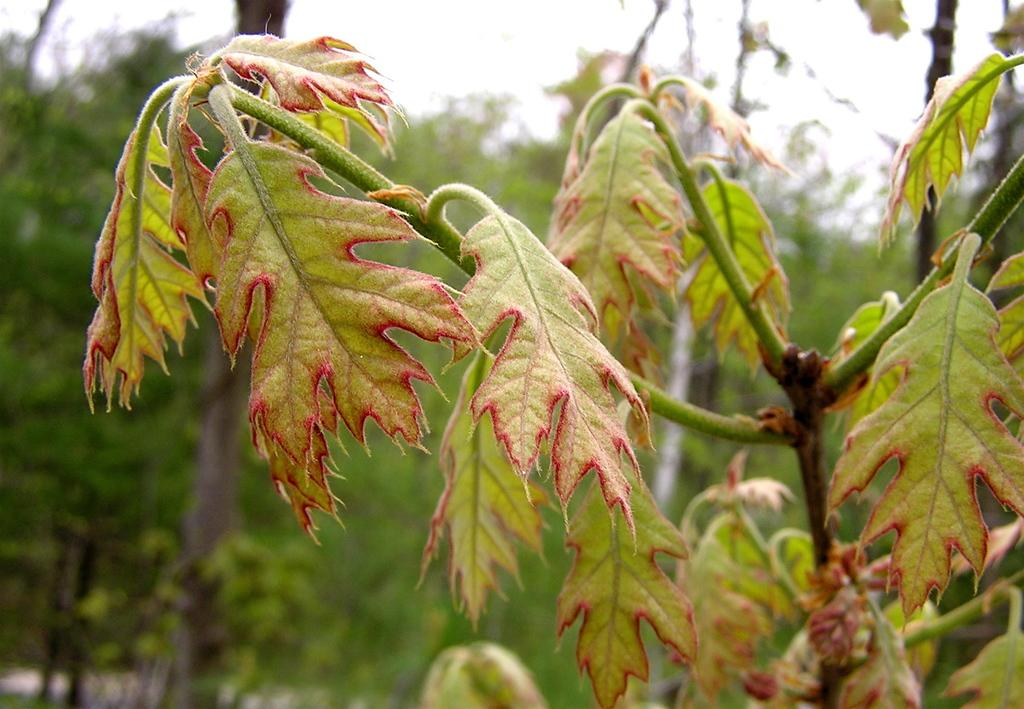What is located on the right side of the image? There is a plant on the right side of the image. How would you describe the background of the image? The background of the image is blurred. What type of vegetation can be seen in the background of the image? Trees are visible in the background of the image. What else is visible in the background of the image? The sky is visible in the background of the image. What type of rice is being served to the army in the image? There is no army or rice present in the image; it features a plant and a blurred background with trees and the sky. 